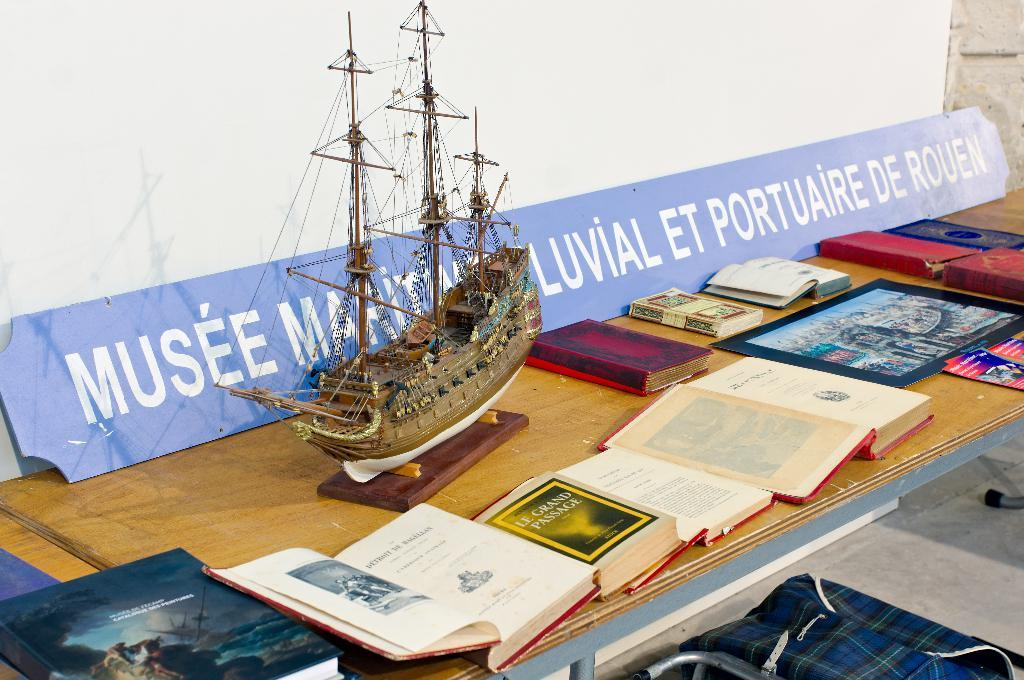Provide a one-sentence caption for the provided image. A table with a display of books and an old model ship and one book is called Le Grand Passage. 